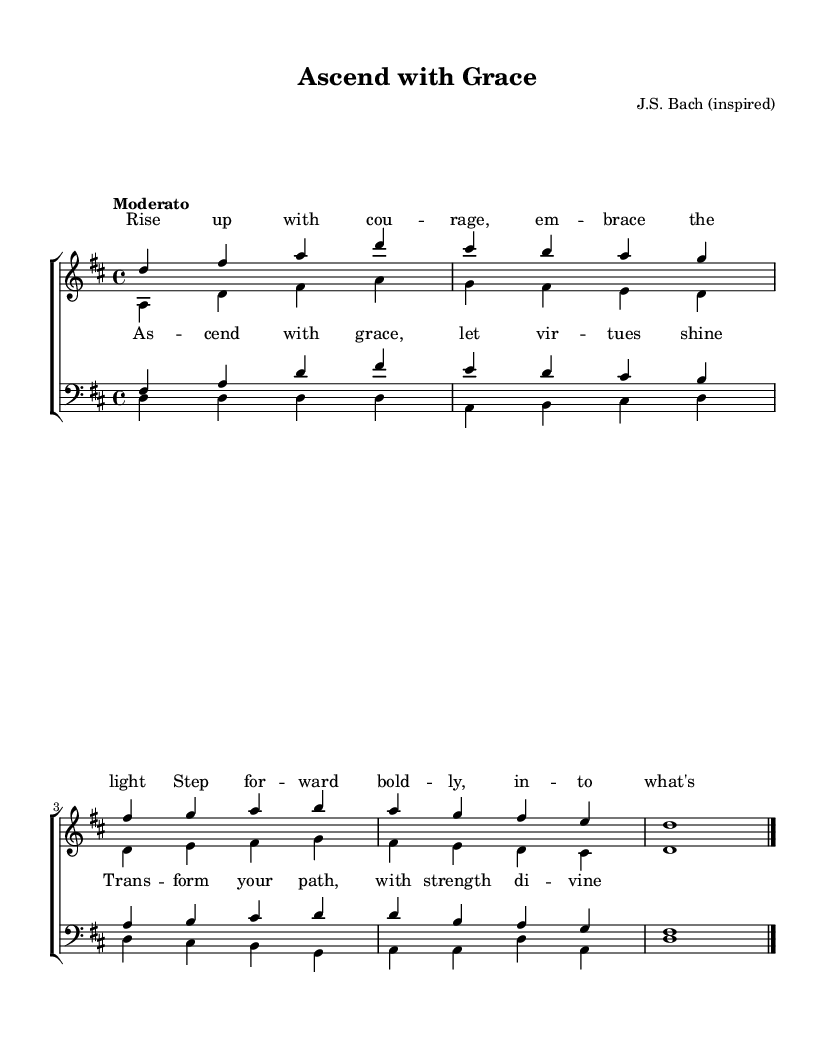What is the key signature of this music? The key signature is D major, which has two sharps (F# and C#). This can be determined by looking at the key signature located at the beginning of the staff lines, and recognizing that two sharps indicate D major.
Answer: D major What is the time signature of this music? The time signature is 4/4. This is indicated at the beginning of the sheet music, where the 4 on top represents four beats per measure, and the 4 on the bottom signifies a quarter note gets one beat.
Answer: 4/4 What is the indicated tempo for this piece? The tempo is marked as "Moderato," indicating a moderate speed for the performance of the piece. This term is commonly used in sheet music to guide the performer on how quickly to play.
Answer: Moderato How many measures are in the soprano part? The soprano part contains five measures, which can be counted by identifying the bar lines that separate each measure within the score.
Answer: 5 What is the primary theme of the lyrics? The primary theme of the lyrics is about uplifting and positive behavior changes, emphasizing courage and stepping forward. The phrases "Rise up with courage" and "Ascend with grace" highlight this focus on positivity.
Answer: Uplifting What vocal parts are included in this choral work? The vocal parts included are sopranos, altos, tenors, and basses, as indicated in the layout of the score where there are sections designated for each of these vocal ranges.
Answer: Sopranos, altos, tenors, basses What is the main musical form of this composition? The main musical form of this composition follows a typical choral structure, where verses and a chorus alternate. This framework is common in Baroque choral works, which often feature multiple parts repeating sections.
Answer: Choral 